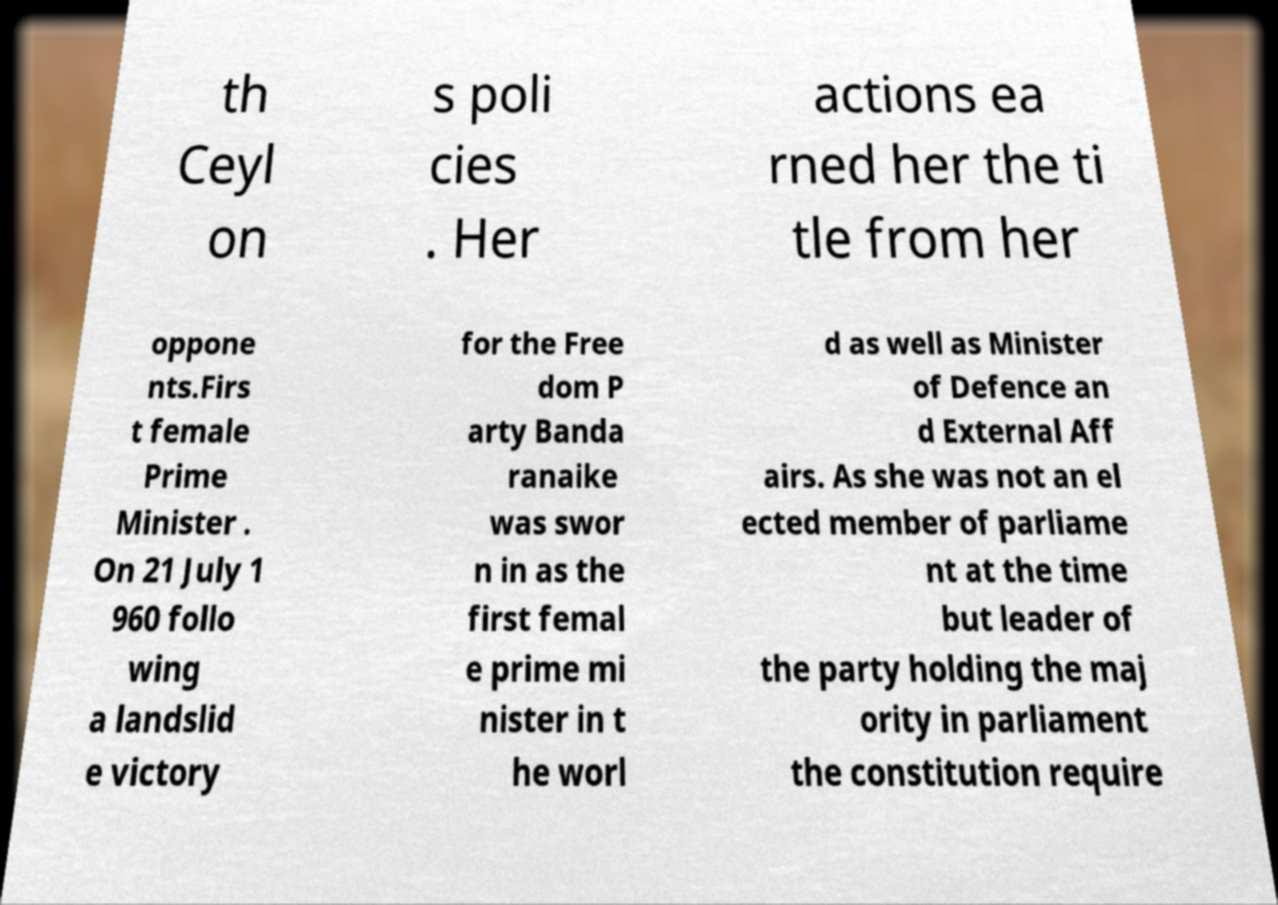Can you accurately transcribe the text from the provided image for me? th Ceyl on s poli cies . Her actions ea rned her the ti tle from her oppone nts.Firs t female Prime Minister . On 21 July 1 960 follo wing a landslid e victory for the Free dom P arty Banda ranaike was swor n in as the first femal e prime mi nister in t he worl d as well as Minister of Defence an d External Aff airs. As she was not an el ected member of parliame nt at the time but leader of the party holding the maj ority in parliament the constitution require 